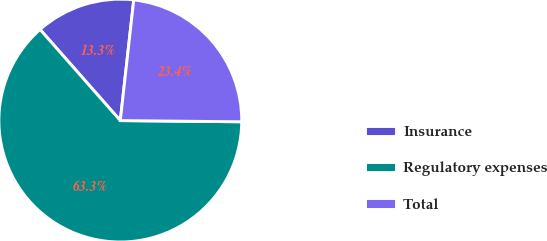Convert chart to OTSL. <chart><loc_0><loc_0><loc_500><loc_500><pie_chart><fcel>Insurance<fcel>Regulatory expenses<fcel>Total<nl><fcel>13.26%<fcel>63.35%<fcel>23.39%<nl></chart> 